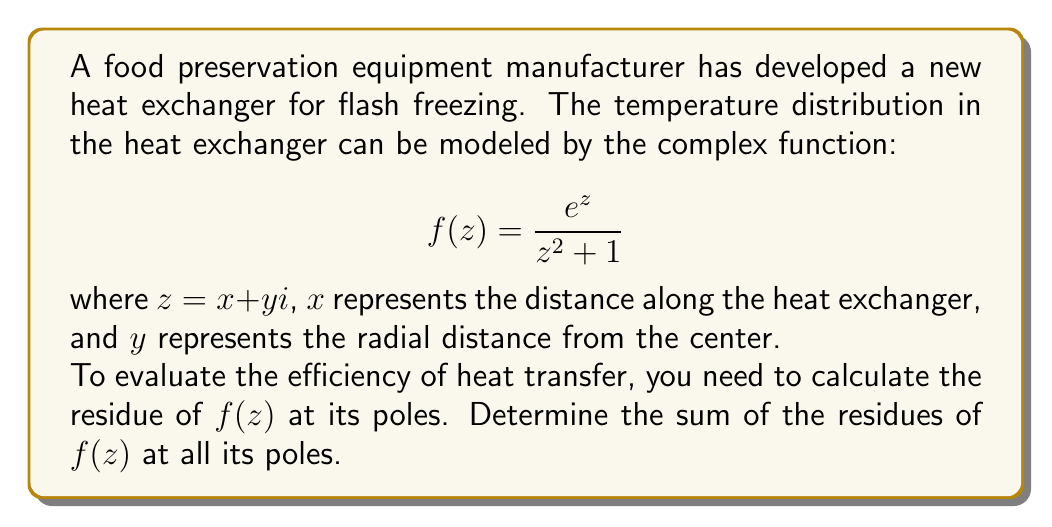Give your solution to this math problem. To solve this problem, we'll follow these steps:

1) First, we need to find the poles of $f(z)$. The poles occur where the denominator of $f(z)$ is zero:

   $$z^2 + 1 = 0$$
   $$z = \pm i$$

   So, the poles are at $z = i$ and $z = -i$.

2) Now, we need to calculate the residue at each pole. Since both poles are simple (order 1), we can use the formula:

   $$\text{Res}(f, a) = \lim_{z \to a} (z-a)f(z)$$

3) For the pole at $z = i$:

   $$\text{Res}(f, i) = \lim_{z \to i} (z-i)\frac{e^z}{z^2 + 1}$$
   $$= \lim_{z \to i} \frac{(z-i)e^z}{(z+i)(z-i)}$$
   $$= \lim_{z \to i} \frac{e^z}{z+i}$$
   $$= \frac{e^i}{2i}$$

4) For the pole at $z = -i$:

   $$\text{Res}(f, -i) = \lim_{z \to -i} (z+i)\frac{e^z}{z^2 + 1}$$
   $$= \lim_{z \to -i} \frac{(z+i)e^z}{(z+i)(z-i)}$$
   $$= \lim_{z \to -i} \frac{e^z}{z-i}$$
   $$= \frac{e^{-i}}{-2i}$$

5) The sum of the residues is:

   $$\text{Res}(f, i) + \text{Res}(f, -i) = \frac{e^i}{2i} - \frac{e^{-i}}{2i}$$
   $$= \frac{e^i - e^{-i}}{2i}$$
   $$= \frac{2i\sin(1)}{2i} = \sin(1)$$

Therefore, the sum of the residues is $\sin(1)$.
Answer: $\sin(1)$ 